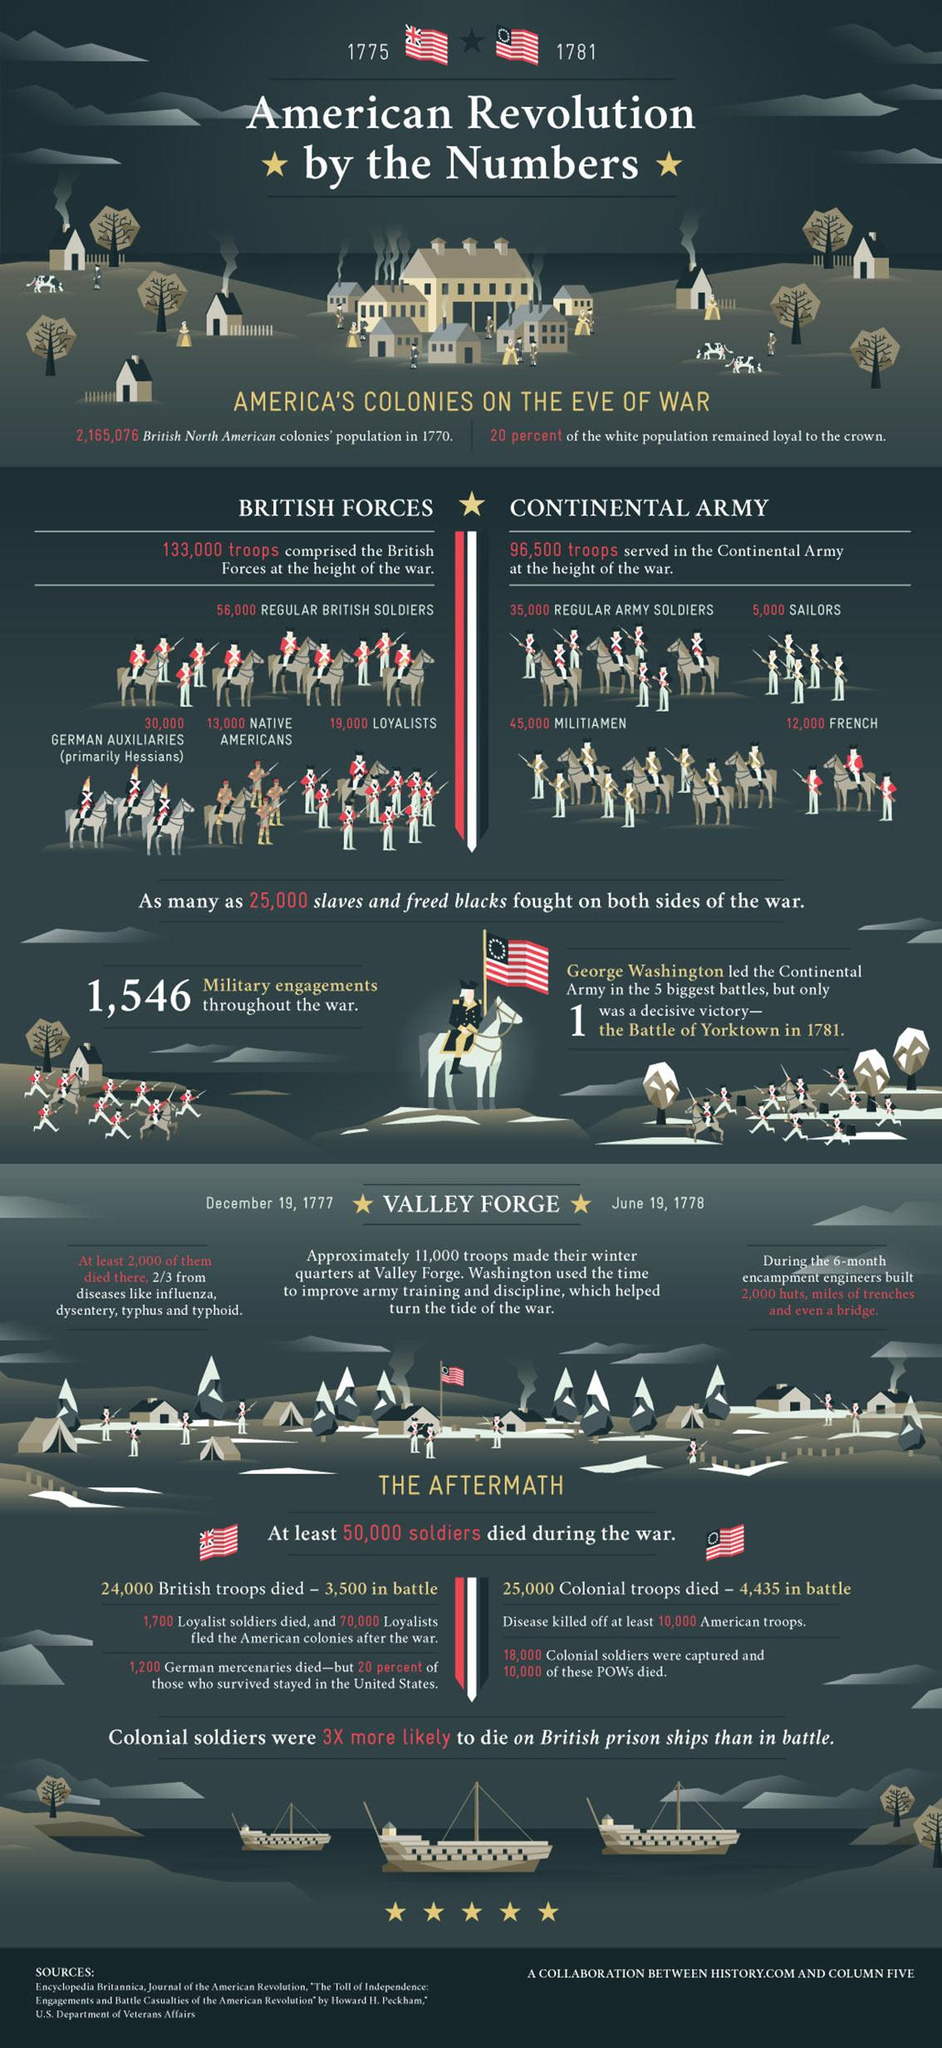Specify some key components in this picture. There are three sources listed at the bottom. During the Revolutionary War, groups other than regular British soldiers were part of the British Forces. These groups included German auxiliaries, Native Americans, and loyalists. The Continental Army was comprised of approximately 57,000 troops, including militiamen and French soldiers. 